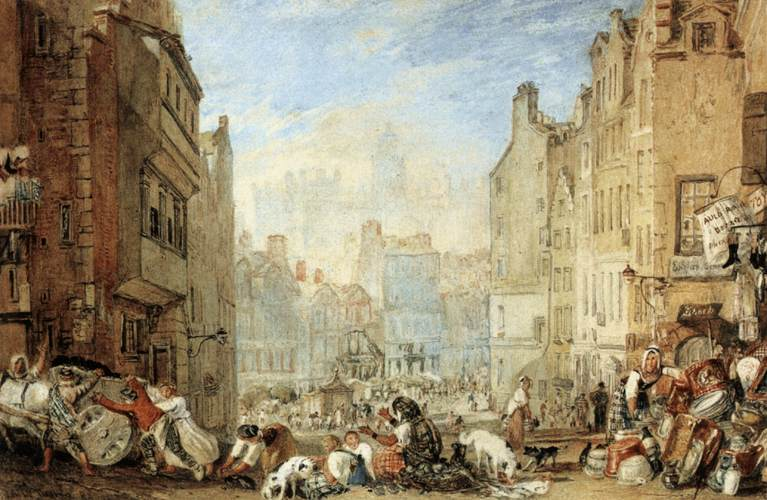Describe the following image. The image shows a vibrant street scene from a historical European city, likely from the 18th or 19th century. The architecture features a mix of medium-height townhouses with classic European design elements such as gabled roofs and shuttered windows. The street is lively with people engaged in various activities, suggesting a market day or similar public gathering. There are people selling goods, children playing, and others in conversation. The image is rich in detail, such as the textures of the buildings, the clothing styles, which allude to a specific historical context, and the expressions and poses of the figures, which add a narrative quality to the scene. The palette of earthy tones, accented with blues and whites, enhances the feeling of a bustling, yet somewhat orderly city life. 